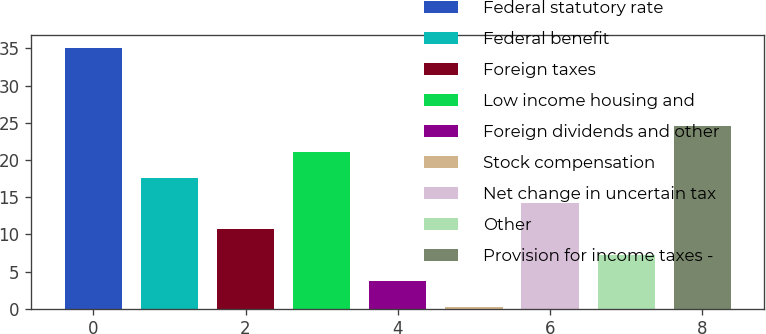<chart> <loc_0><loc_0><loc_500><loc_500><bar_chart><fcel>Federal statutory rate<fcel>Federal benefit<fcel>Foreign taxes<fcel>Low income housing and<fcel>Foreign dividends and other<fcel>Stock compensation<fcel>Net change in uncertain tax<fcel>Other<fcel>Provision for income taxes -<nl><fcel>35<fcel>17.65<fcel>10.71<fcel>21.12<fcel>3.77<fcel>0.3<fcel>14.18<fcel>7.24<fcel>24.59<nl></chart> 